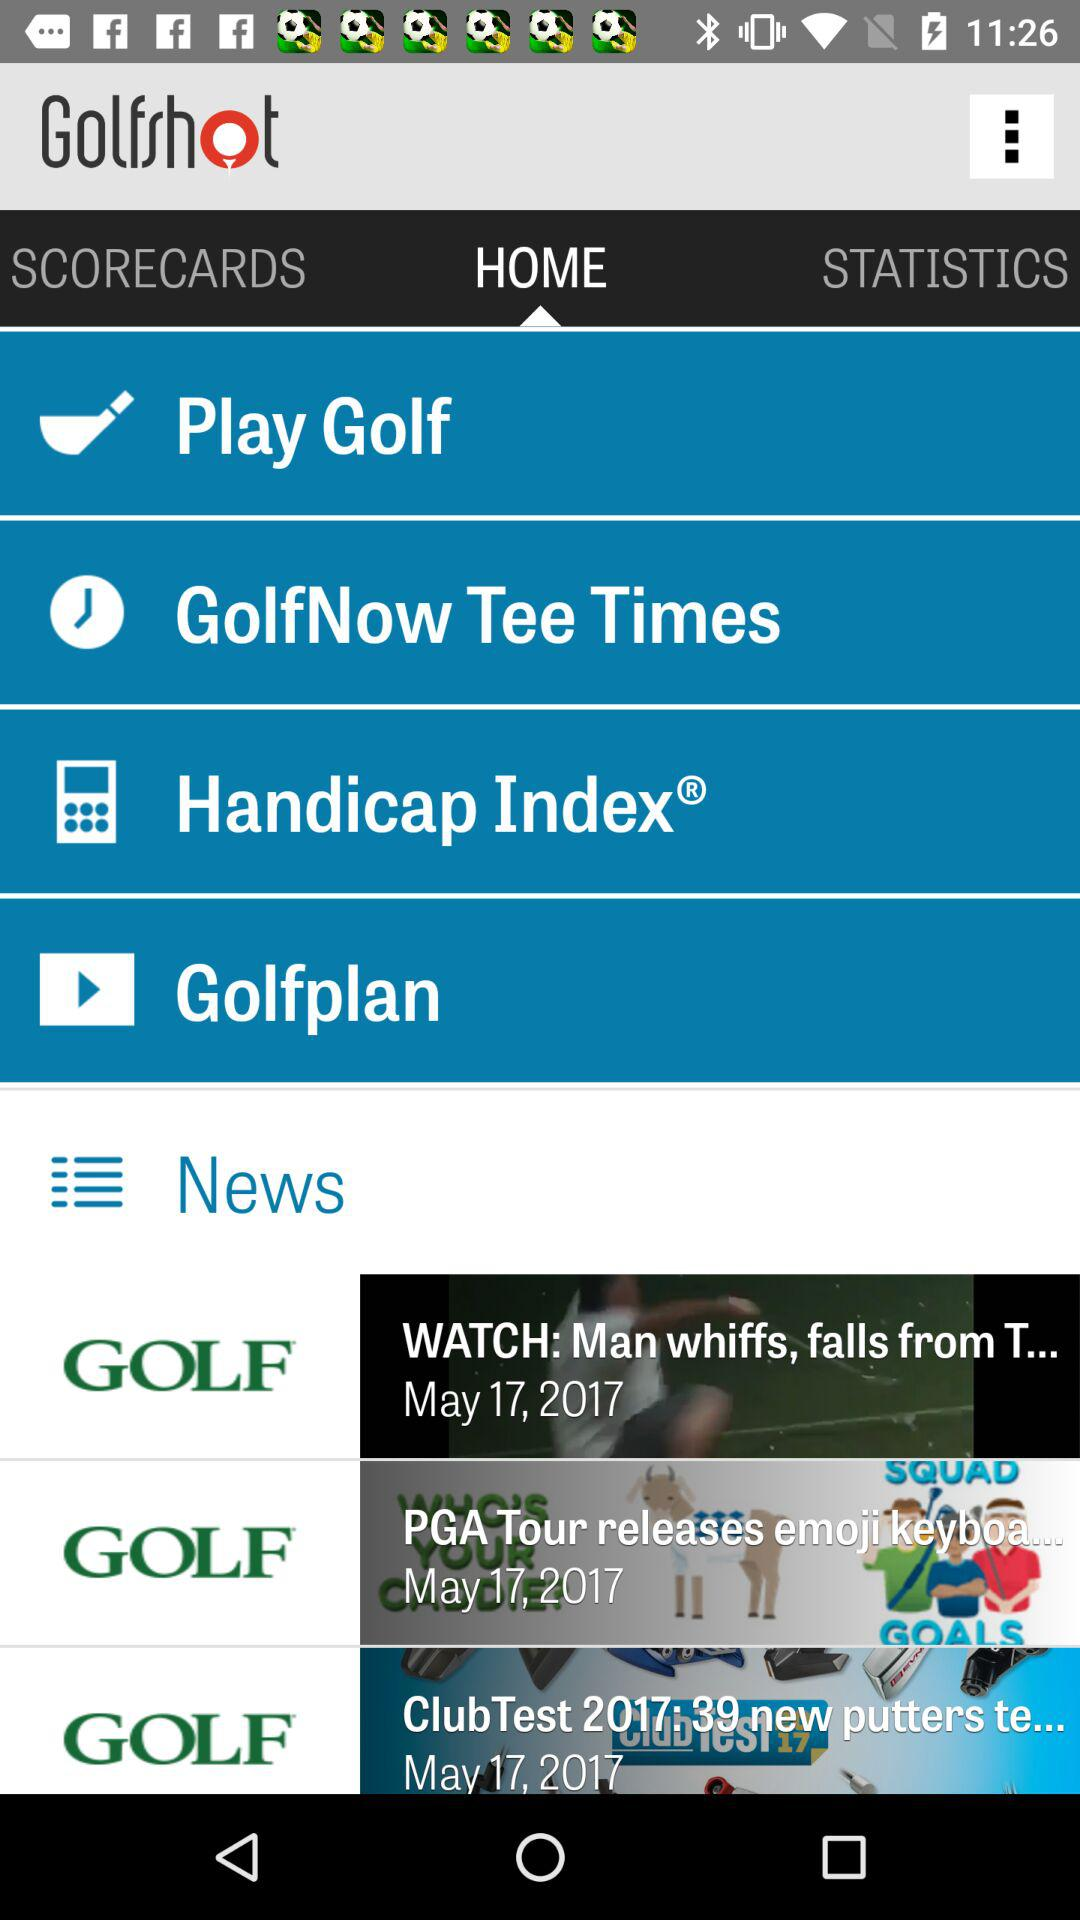Which option is selected? The selected option is "HOME". 